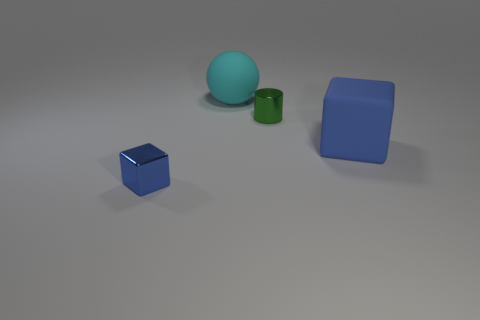What could be the purpose of arranging these objects in this manner? This arrangement of objects may serve several purposes. It could be a visual composition created to study shapes, colors, and shadows in 3D rendering programs. Alternatively, it might be an educational setup designed to demonstrate principles of geometry and spatial relations. Or, it may simply be an aesthetically pleasing arrangement for creative or decorative purposes. 